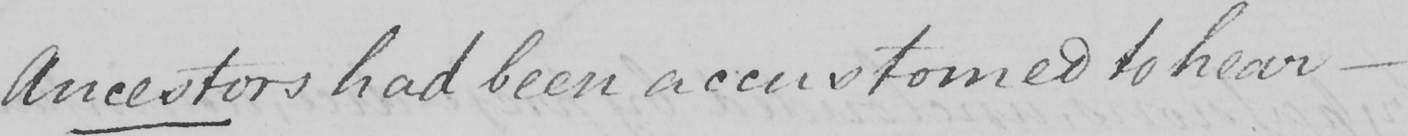What text is written in this handwritten line? Ancestors had been accustomed to hear  _ 